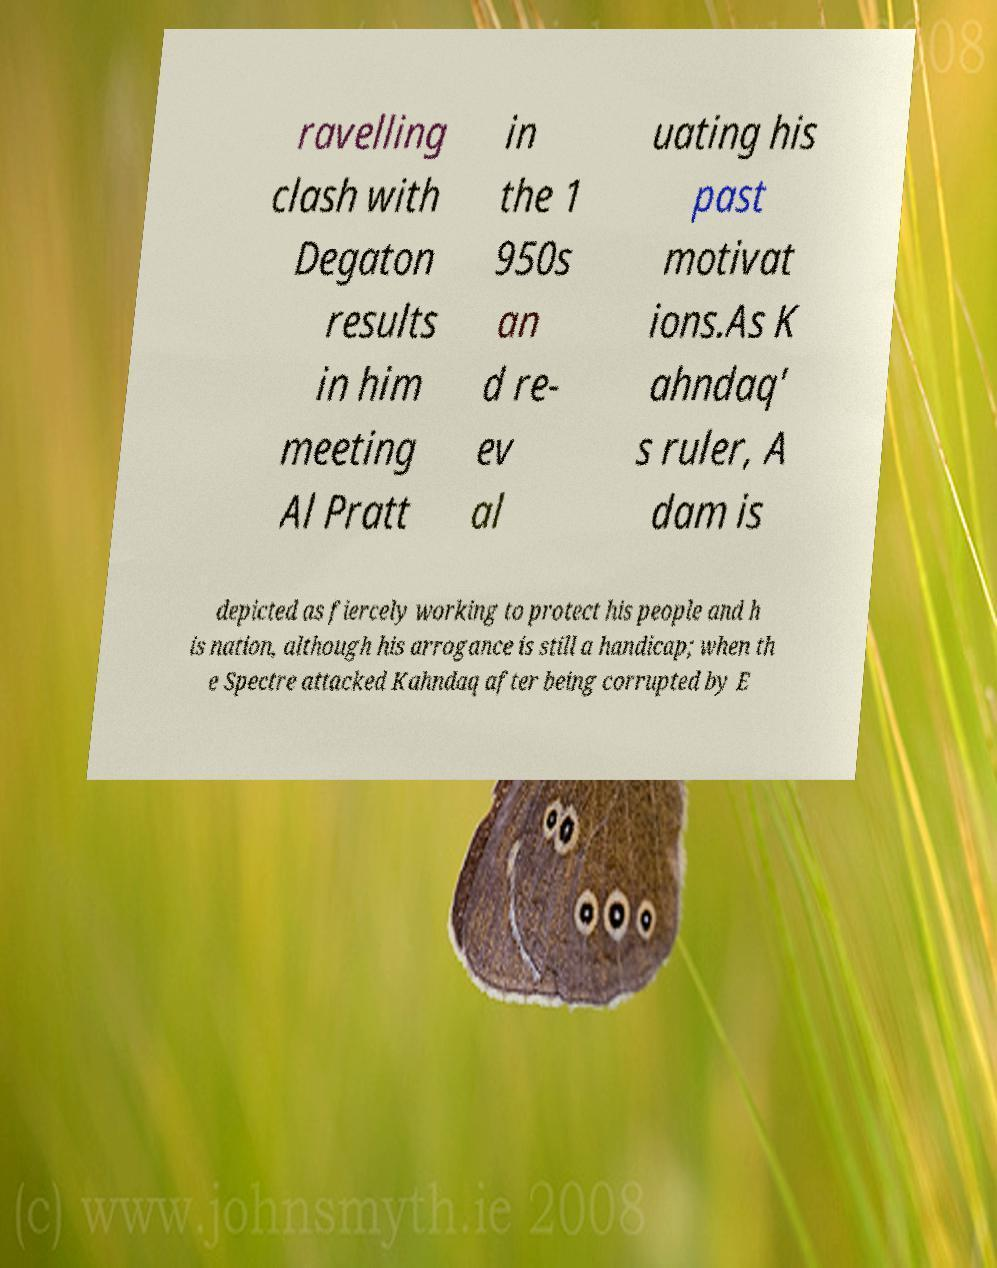There's text embedded in this image that I need extracted. Can you transcribe it verbatim? ravelling clash with Degaton results in him meeting Al Pratt in the 1 950s an d re- ev al uating his past motivat ions.As K ahndaq' s ruler, A dam is depicted as fiercely working to protect his people and h is nation, although his arrogance is still a handicap; when th e Spectre attacked Kahndaq after being corrupted by E 